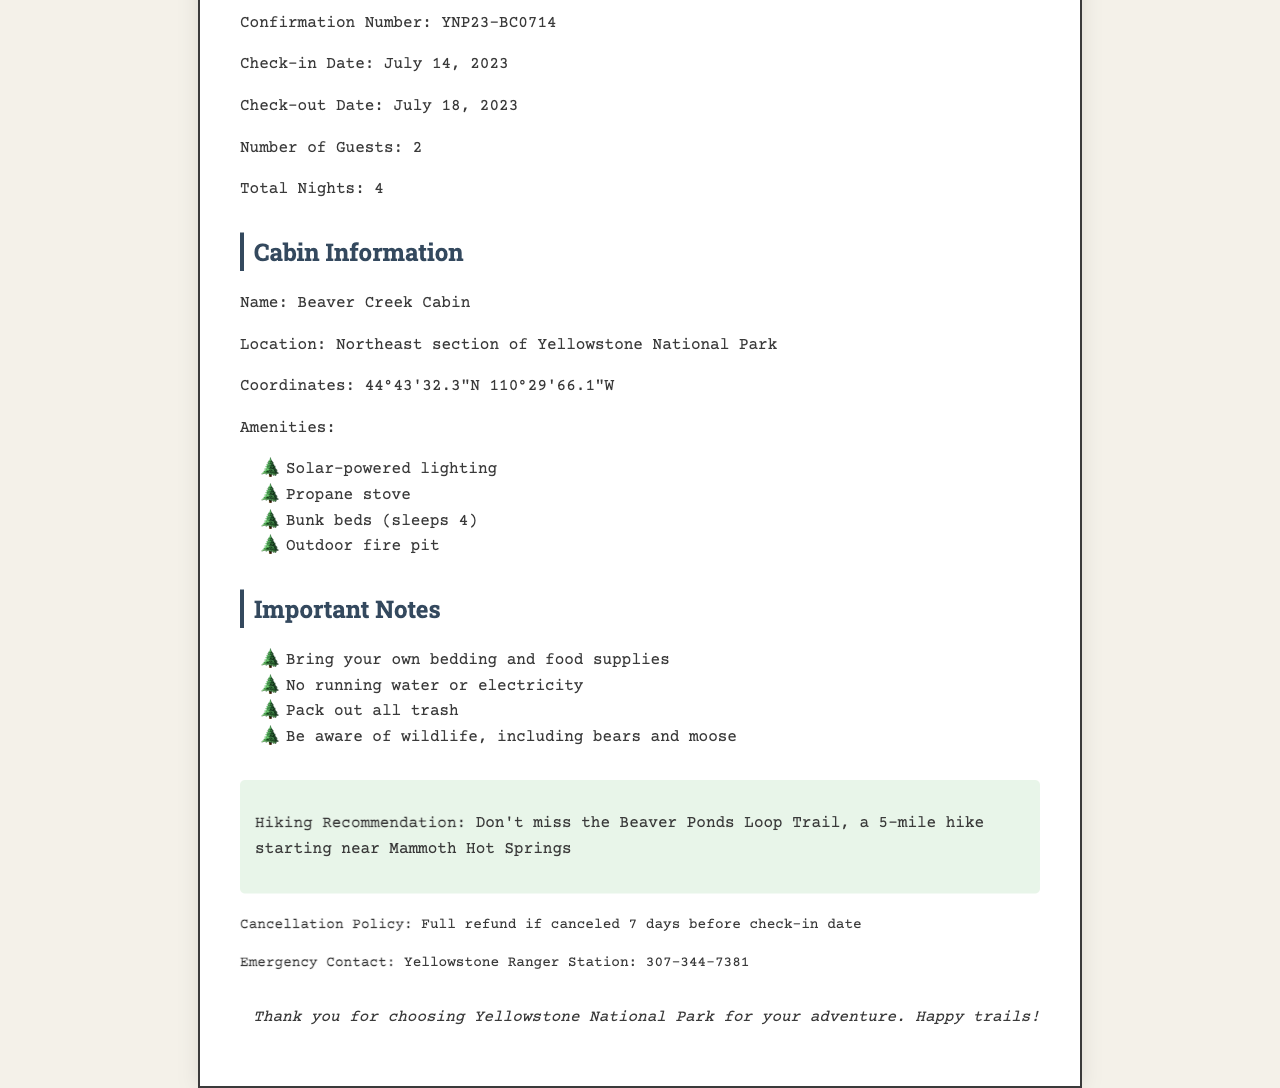What is the confirmation number? The confirmation number is a specific identifier for the reservation mentioned in the document. It is YNP23-BC0714.
Answer: YNP23-BC0714 What are the check-in and check-out dates? The check-in and check-out dates indicate the period during which the cabin is reserved. They are July 14, 2023, and July 18, 2023, respectively.
Answer: July 14, 2023, and July 18, 2023 How many guests can stay at the cabin? The document specifies the number of guests that can occupy the cabin, which is 2.
Answer: 2 What is a notable hiking recommendation? The recommendation provides information on a particular hiking trail nearby, enhancing the hiking experience during the stay. The trail mentioned is the Beaver Ponds Loop Trail.
Answer: Beaver Ponds Loop Trail What is the cancellation policy? The cancellation policy outlines the terms for canceling the reservation, including any refund details. It states full refund if canceled 7 days before check-in date.
Answer: Full refund if canceled 7 days before check-in date Where is the cabin located? The location specifies where the cabin can be found within the national park. It is located in the northeast section of Yellowstone National Park.
Answer: Northeast section of Yellowstone National Park Is running water available at the cabin? This question evaluates the amenities provided at the cabin, particularly about water availability. The information in the document states that there is no running water.
Answer: No What should guests bring to the cabin? This question addresses the important notes section that informs guests of supplies they need to bring for their stay. Guests should bring their own bedding and food supplies.
Answer: Bedding and food supplies What is the emergency contact number? The emergency contact provides crucial information for guests in case of need for assistance during their stay. The number is 307-344-7381.
Answer: 307-344-7381 